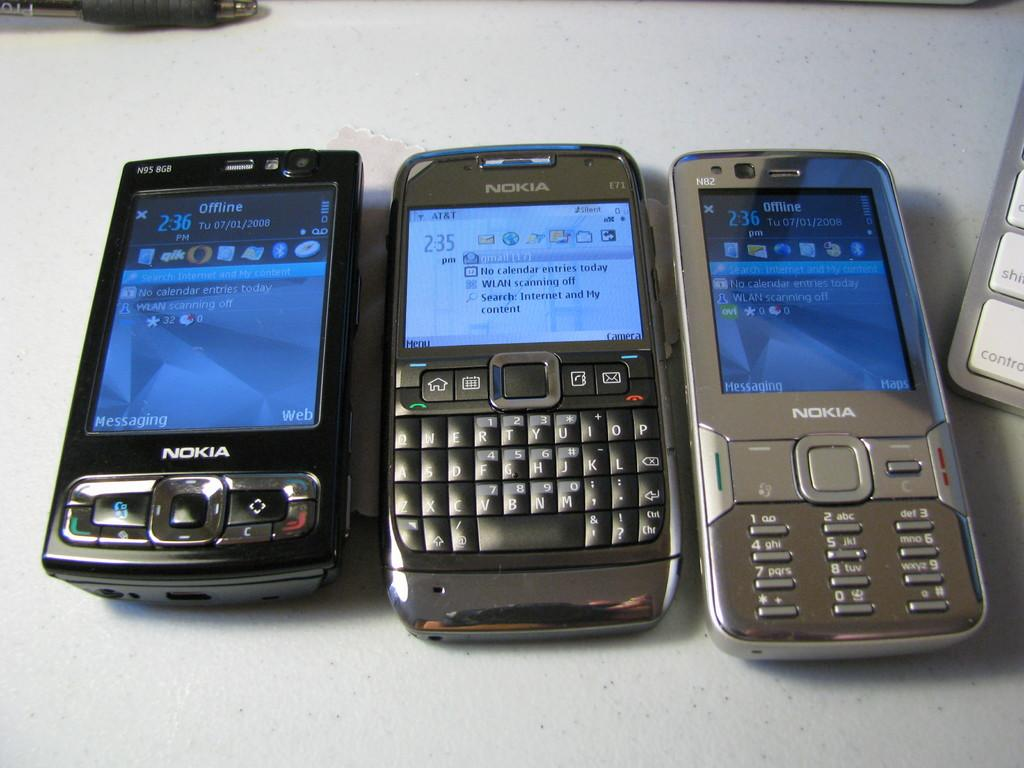How many mobile phones are visible in the image? There are three mobile phones in the image. What else can be seen in the image besides the mobile phones? There is an object and a pen at the top of the image. Can you describe the object below the mobile phones? There is some object below the mobile phones, but its specific details are not mentioned in the facts. How many children are playing with the mobile phones in the image? There are no children present in the image, and the mobile phones are not being used by anyone. Can you describe the stretch of land visible in the image? There is no mention of a stretch of land in the image; the facts only mention mobile phones, an object, a pen, and an unspecified object below the mobile phones. 